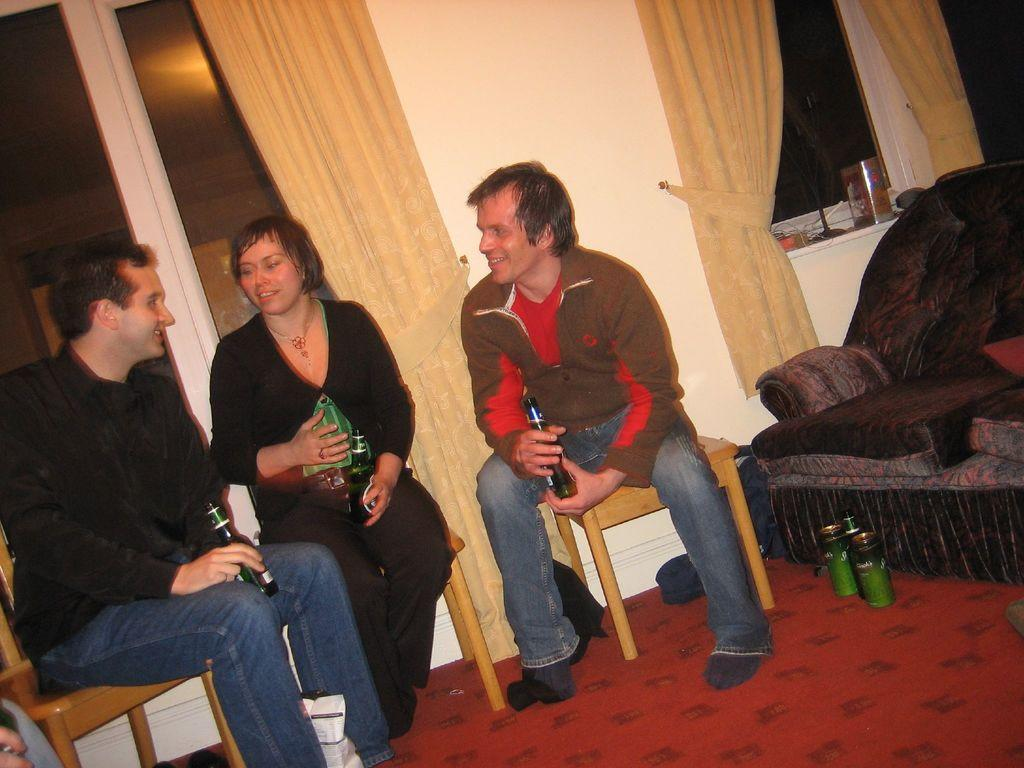How many people are in the image? There are two men and one woman in the image, making a total of three people. What are the individuals doing in the image? The individuals are sitting on chairs and holding bottles in their hands. What is the facial expression of the people in the image? The individuals are smiling in the image. What can be seen in the background of the image? There are windows with curtains and sofas in the background, as well as tins on the floor. What type of cable is being used by the individuals in the image? There is no cable visible in the image; the individuals are holding bottles. What kind of competition is taking place in the image? There is no competition present in the image; it simply shows three people sitting and holding bottles. 